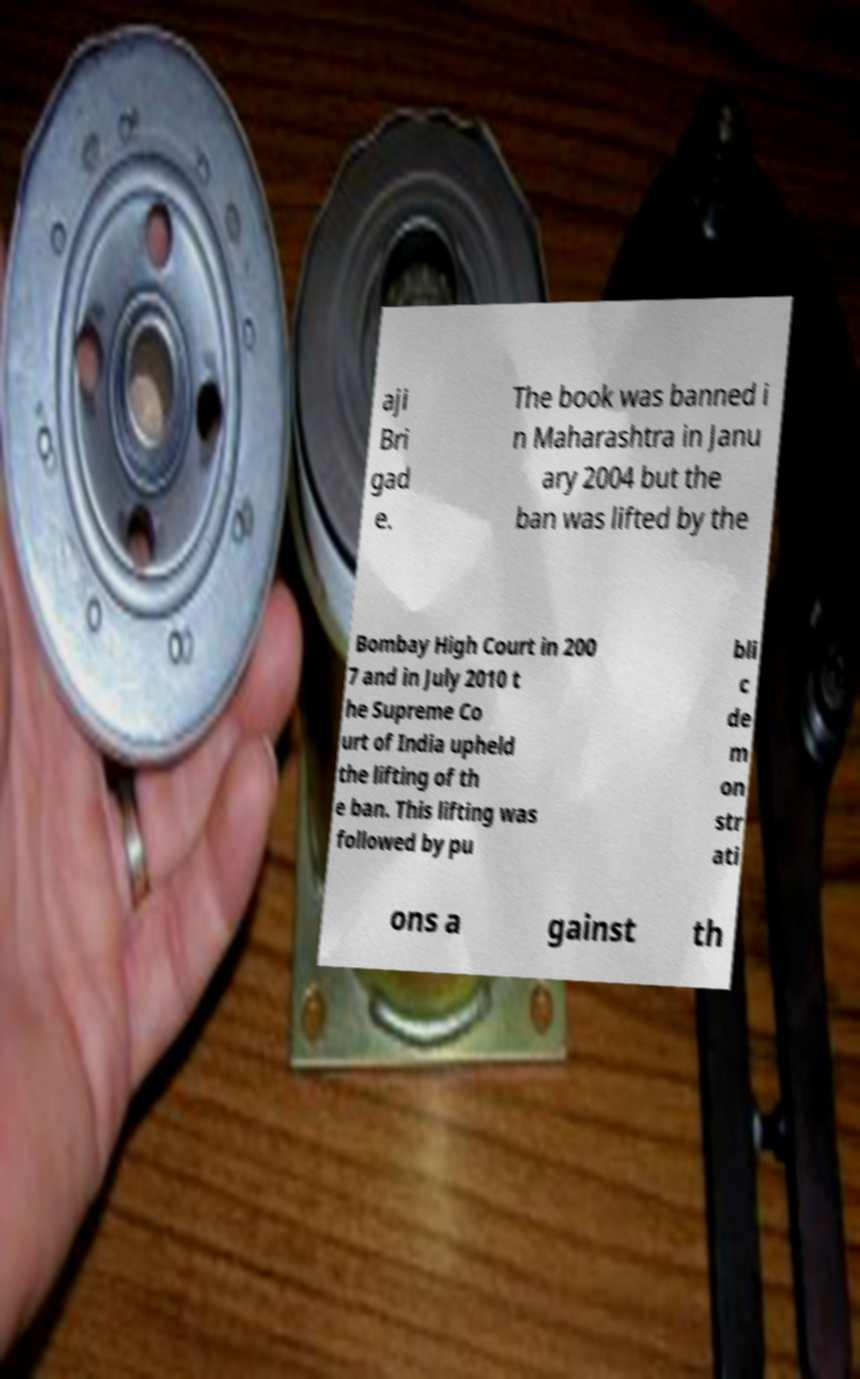Can you read and provide the text displayed in the image?This photo seems to have some interesting text. Can you extract and type it out for me? aji Bri gad e. The book was banned i n Maharashtra in Janu ary 2004 but the ban was lifted by the Bombay High Court in 200 7 and in July 2010 t he Supreme Co urt of India upheld the lifting of th e ban. This lifting was followed by pu bli c de m on str ati ons a gainst th 